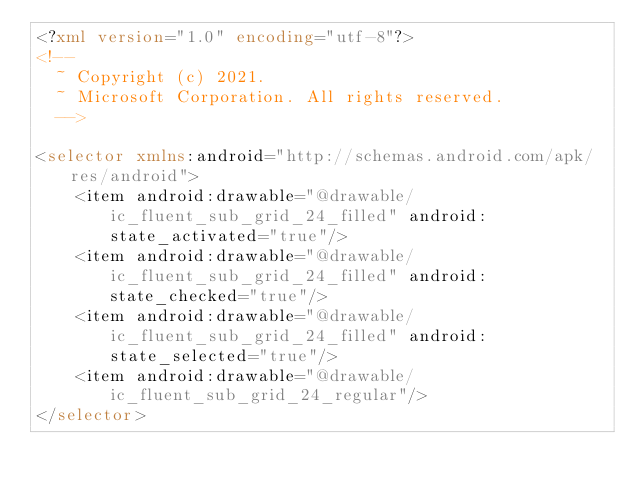Convert code to text. <code><loc_0><loc_0><loc_500><loc_500><_XML_><?xml version="1.0" encoding="utf-8"?>
<!--
  ~ Copyright (c) 2021.
  ~ Microsoft Corporation. All rights reserved.
  -->

<selector xmlns:android="http://schemas.android.com/apk/res/android">
    <item android:drawable="@drawable/ic_fluent_sub_grid_24_filled" android:state_activated="true"/>
    <item android:drawable="@drawable/ic_fluent_sub_grid_24_filled" android:state_checked="true"/>
    <item android:drawable="@drawable/ic_fluent_sub_grid_24_filled" android:state_selected="true"/>
    <item android:drawable="@drawable/ic_fluent_sub_grid_24_regular"/>
</selector>
</code> 